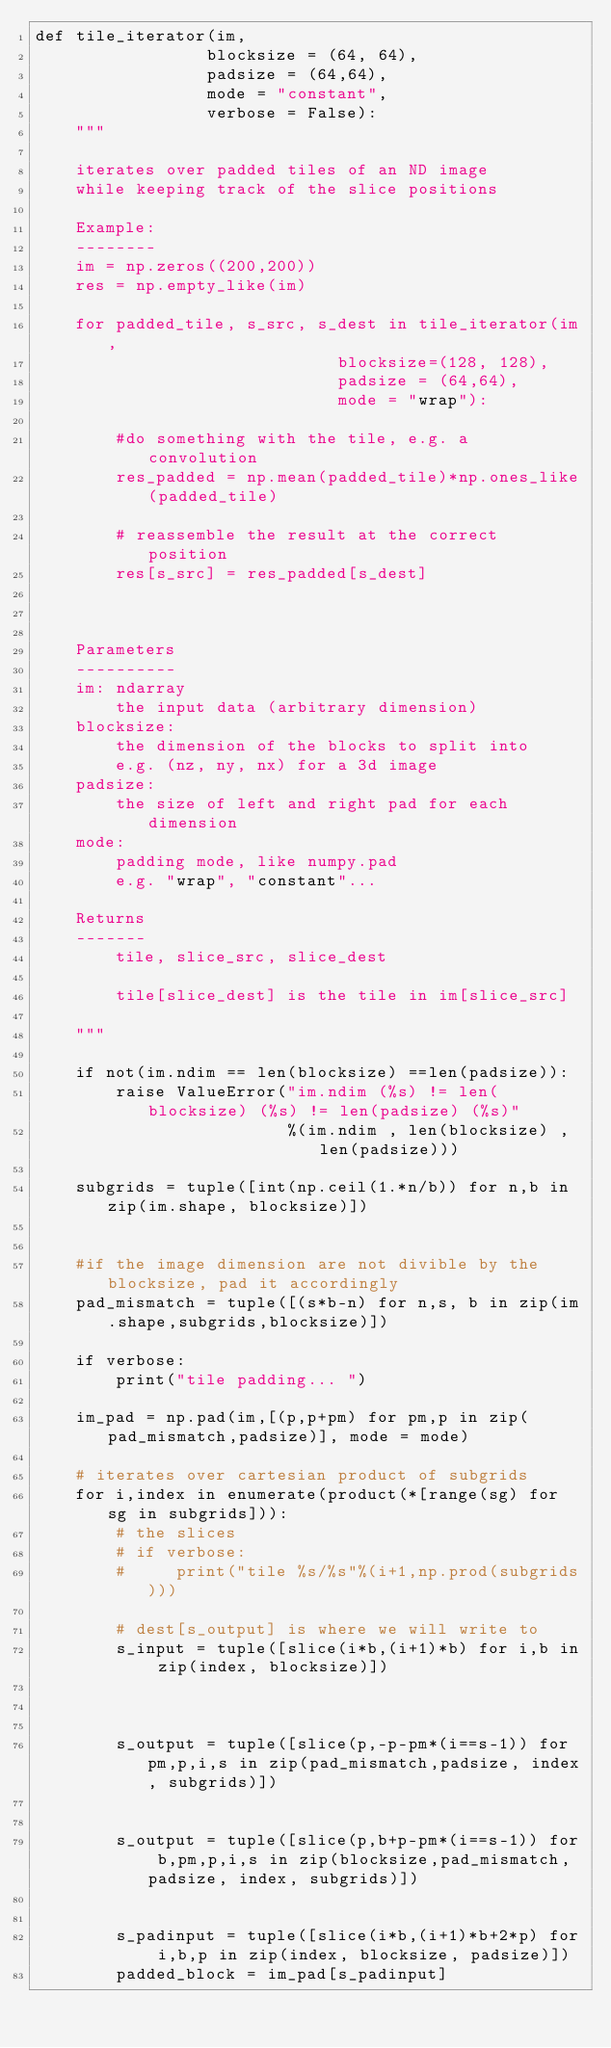Convert code to text. <code><loc_0><loc_0><loc_500><loc_500><_Python_>def tile_iterator(im,
                 blocksize = (64, 64),
                 padsize = (64,64),
                 mode = "constant",
                 verbose = False):
    """

    iterates over padded tiles of an ND image 
    while keeping track of the slice positions

    Example:
    --------
    im = np.zeros((200,200))
    res = np.empty_like(im)

    for padded_tile, s_src, s_dest in tile_iterator(im,
                              blocksize=(128, 128),
                              padsize = (64,64),
                              mode = "wrap"):

        #do something with the tile, e.g. a convolution
        res_padded = np.mean(padded_tile)*np.ones_like(padded_tile)

        # reassemble the result at the correct position
        res[s_src] = res_padded[s_dest]



    Parameters
    ----------
    im: ndarray
        the input data (arbitrary dimension)
    blocksize:
        the dimension of the blocks to split into
        e.g. (nz, ny, nx) for a 3d image
    padsize:
        the size of left and right pad for each dimension
    mode:
        padding mode, like numpy.pad
        e.g. "wrap", "constant"...

    Returns
    -------
        tile, slice_src, slice_dest

        tile[slice_dest] is the tile in im[slice_src]

    """

    if not(im.ndim == len(blocksize) ==len(padsize)):
        raise ValueError("im.ndim (%s) != len(blocksize) (%s) != len(padsize) (%s)"
                         %(im.ndim , len(blocksize) , len(padsize)))

    subgrids = tuple([int(np.ceil(1.*n/b)) for n,b in zip(im.shape, blocksize)])


    #if the image dimension are not divible by the blocksize, pad it accordingly
    pad_mismatch = tuple([(s*b-n) for n,s, b in zip(im.shape,subgrids,blocksize)])

    if verbose:
        print("tile padding... ")

    im_pad = np.pad(im,[(p,p+pm) for pm,p in zip(pad_mismatch,padsize)], mode = mode)

    # iterates over cartesian product of subgrids
    for i,index in enumerate(product(*[range(sg) for sg in subgrids])):
        # the slices
        # if verbose:
        #     print("tile %s/%s"%(i+1,np.prod(subgrids)))

        # dest[s_output] is where we will write to
        s_input = tuple([slice(i*b,(i+1)*b) for i,b in zip(index, blocksize)])



        s_output = tuple([slice(p,-p-pm*(i==s-1)) for pm,p,i,s in zip(pad_mismatch,padsize, index, subgrids)])


        s_output = tuple([slice(p,b+p-pm*(i==s-1)) for b,pm,p,i,s in zip(blocksize,pad_mismatch,padsize, index, subgrids)])


        s_padinput = tuple([slice(i*b,(i+1)*b+2*p) for i,b,p in zip(index, blocksize, padsize)])
        padded_block = im_pad[s_padinput]
</code> 